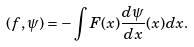Convert formula to latex. <formula><loc_0><loc_0><loc_500><loc_500>( f , \psi ) = - \int F ( x ) \frac { d \psi } { d x } ( x ) d x .</formula> 